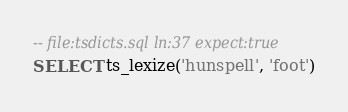Convert code to text. <code><loc_0><loc_0><loc_500><loc_500><_SQL_>-- file:tsdicts.sql ln:37 expect:true
SELECT ts_lexize('hunspell', 'foot')
</code> 